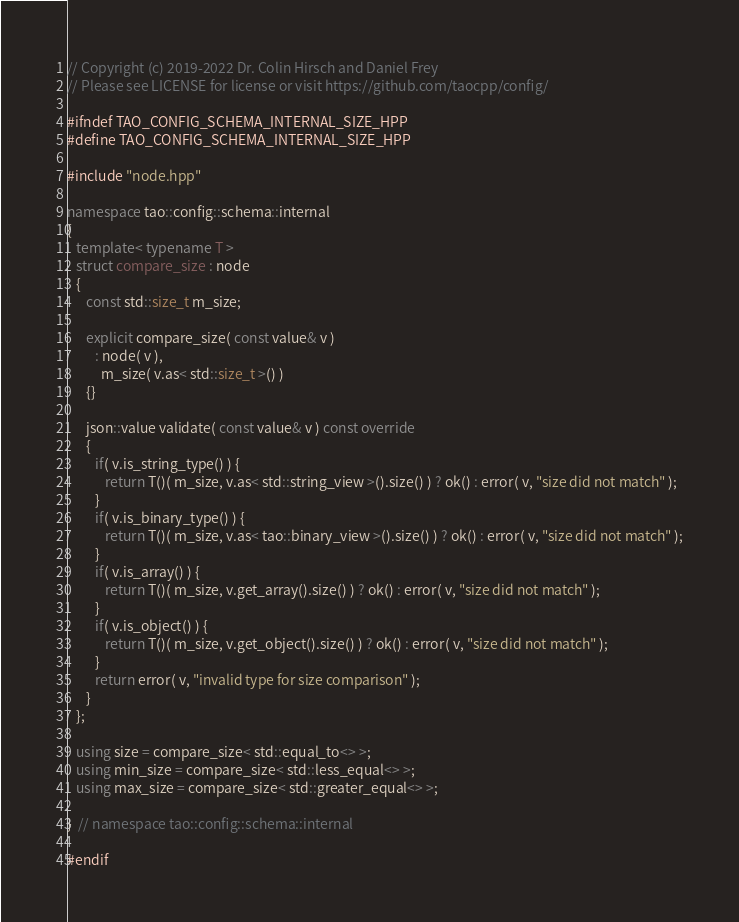<code> <loc_0><loc_0><loc_500><loc_500><_C++_>// Copyright (c) 2019-2022 Dr. Colin Hirsch and Daniel Frey
// Please see LICENSE for license or visit https://github.com/taocpp/config/

#ifndef TAO_CONFIG_SCHEMA_INTERNAL_SIZE_HPP
#define TAO_CONFIG_SCHEMA_INTERNAL_SIZE_HPP

#include "node.hpp"

namespace tao::config::schema::internal
{
   template< typename T >
   struct compare_size : node
   {
      const std::size_t m_size;

      explicit compare_size( const value& v )
         : node( v ),
           m_size( v.as< std::size_t >() )
      {}

      json::value validate( const value& v ) const override
      {
         if( v.is_string_type() ) {
            return T()( m_size, v.as< std::string_view >().size() ) ? ok() : error( v, "size did not match" );
         }
         if( v.is_binary_type() ) {
            return T()( m_size, v.as< tao::binary_view >().size() ) ? ok() : error( v, "size did not match" );
         }
         if( v.is_array() ) {
            return T()( m_size, v.get_array().size() ) ? ok() : error( v, "size did not match" );
         }
         if( v.is_object() ) {
            return T()( m_size, v.get_object().size() ) ? ok() : error( v, "size did not match" );
         }
         return error( v, "invalid type for size comparison" );
      }
   };

   using size = compare_size< std::equal_to<> >;
   using min_size = compare_size< std::less_equal<> >;
   using max_size = compare_size< std::greater_equal<> >;

}  // namespace tao::config::schema::internal

#endif
</code> 